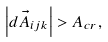<formula> <loc_0><loc_0><loc_500><loc_500>\left | d \vec { A } _ { i j k } \right | > A _ { c r } ,</formula> 